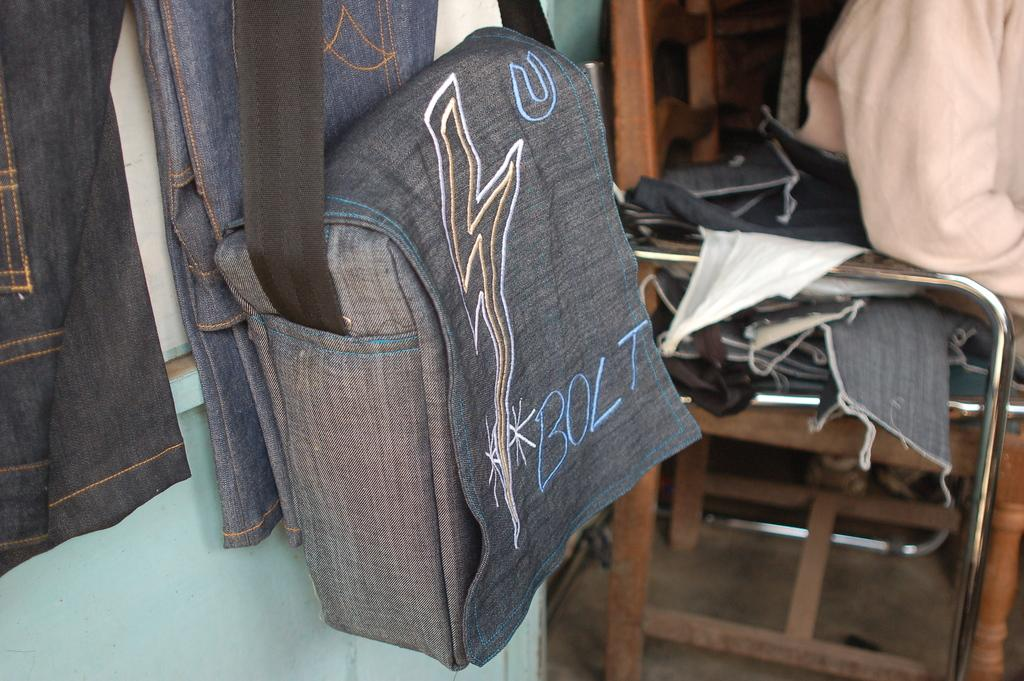What object can be seen in the image that is commonly used for carrying personal items? There is a handbag in the image. What word is written on the handbag? The handbag has "bolt" written on it. What type of furniture can be seen in the background of the image? There is a chair in the background of the image. Can you describe the nest that is visible in the image? There is no nest present in the image. What type of liquid can be seen spilling out of the handbag in the image? There is no liquid visible in the image; it is a handbag with the word "bolt" written on it. 